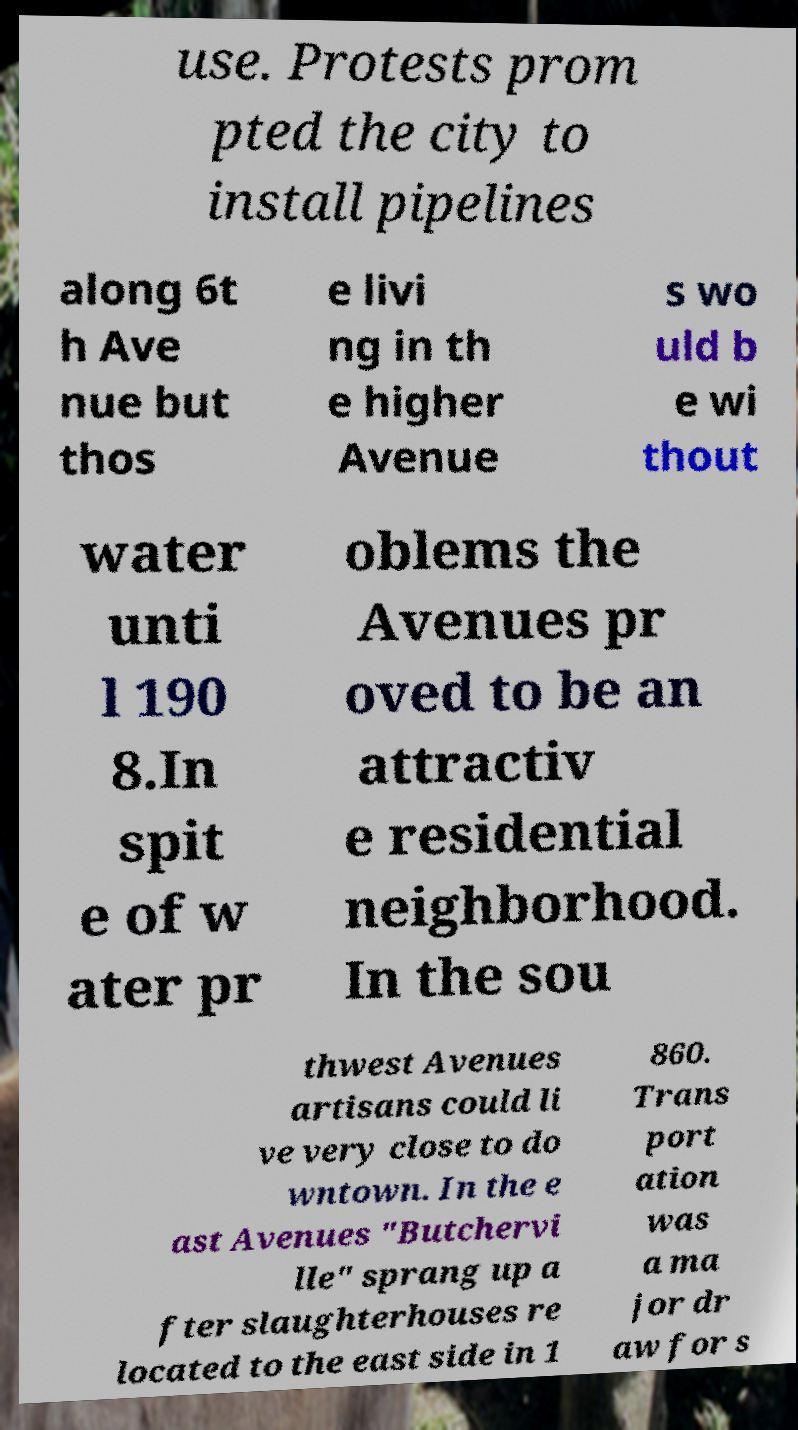Could you extract and type out the text from this image? use. Protests prom pted the city to install pipelines along 6t h Ave nue but thos e livi ng in th e higher Avenue s wo uld b e wi thout water unti l 190 8.In spit e of w ater pr oblems the Avenues pr oved to be an attractiv e residential neighborhood. In the sou thwest Avenues artisans could li ve very close to do wntown. In the e ast Avenues "Butchervi lle" sprang up a fter slaughterhouses re located to the east side in 1 860. Trans port ation was a ma jor dr aw for s 